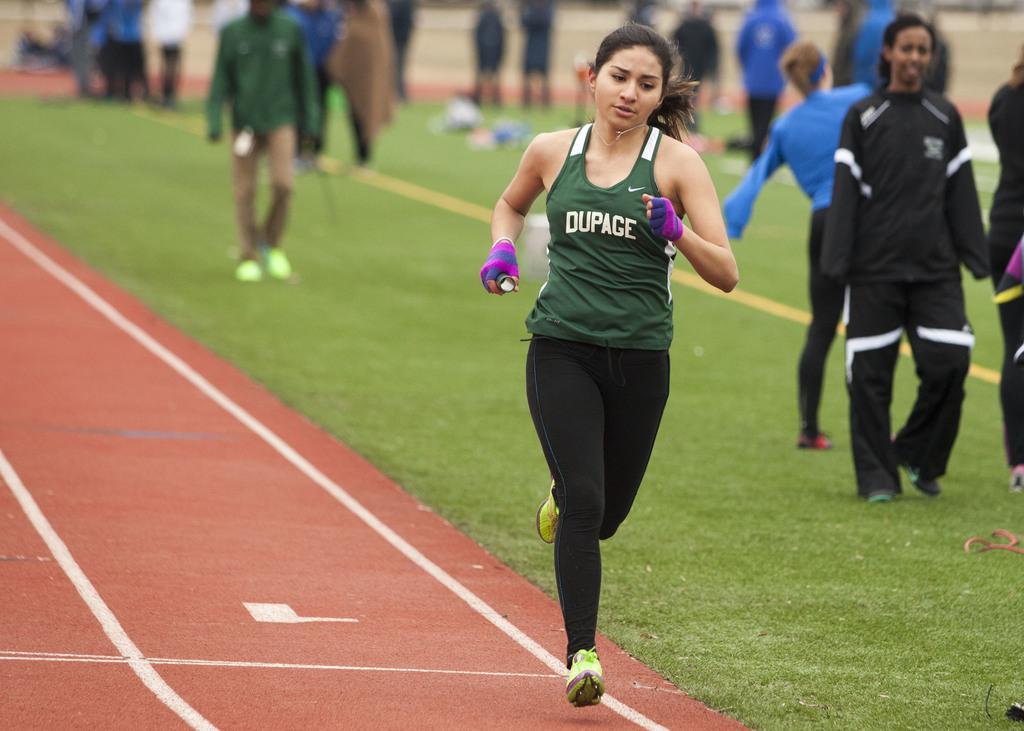In one or two sentences, can you explain what this image depicts? In this image I can see a woman wearing green and white colored top and black pant is running on the ground. In the background I can see some grass, few other persons standing on the ground and few other objects on the ground. 